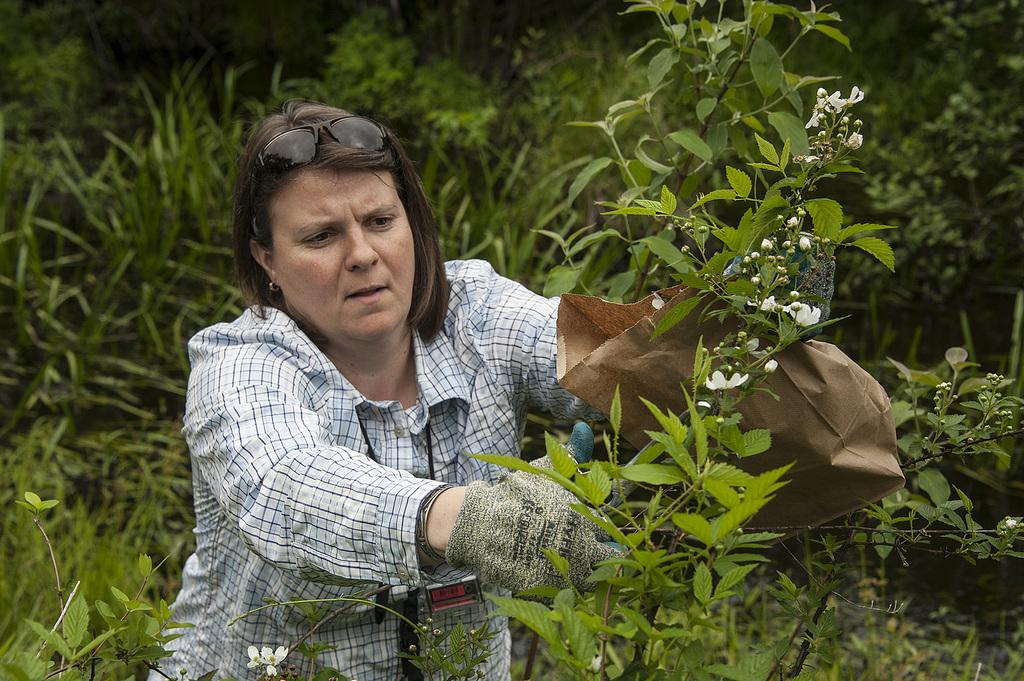What is the person in the image doing? The person is standing in the image and holding a carry bag and a pair of scissors. What might the person be planning to do with the scissors? It is unclear what the person intends to do with the scissors, but they are holding them in their hand. What can be seen in the backdrop of the image? There are plants and trees in the backdrop of the image. What type of songs can be heard playing in the background of the image? There is no indication of any songs or music in the image, so it cannot be determined what type of songs might be playing. 